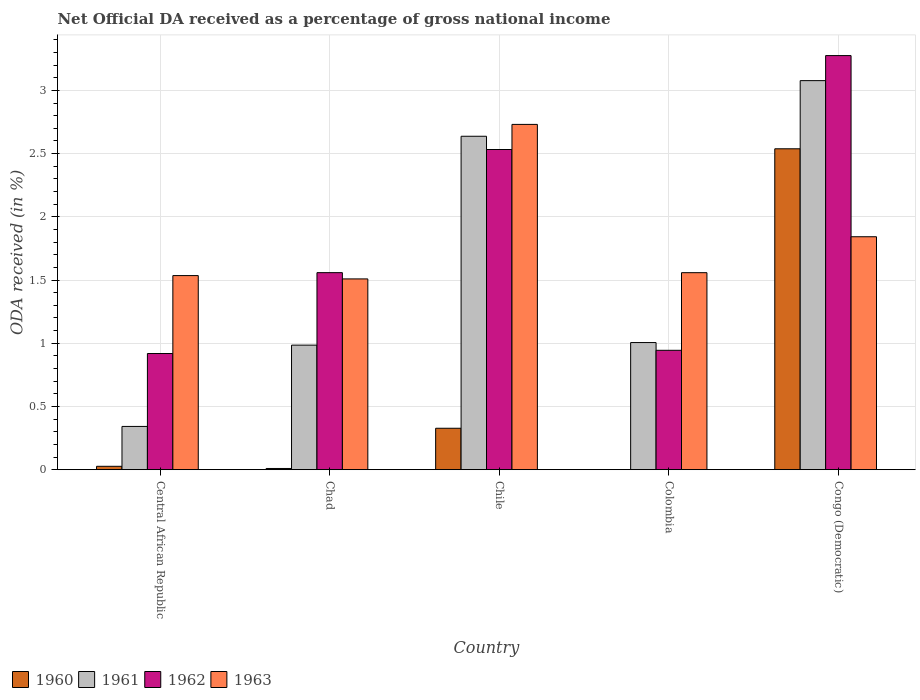How many different coloured bars are there?
Make the answer very short. 4. How many groups of bars are there?
Your response must be concise. 5. Are the number of bars per tick equal to the number of legend labels?
Keep it short and to the point. No. Are the number of bars on each tick of the X-axis equal?
Your answer should be very brief. No. How many bars are there on the 3rd tick from the right?
Provide a succinct answer. 4. What is the label of the 4th group of bars from the left?
Give a very brief answer. Colombia. In how many cases, is the number of bars for a given country not equal to the number of legend labels?
Offer a very short reply. 1. What is the net official DA received in 1963 in Colombia?
Give a very brief answer. 1.56. Across all countries, what is the maximum net official DA received in 1962?
Offer a terse response. 3.28. Across all countries, what is the minimum net official DA received in 1963?
Keep it short and to the point. 1.51. In which country was the net official DA received in 1961 maximum?
Your response must be concise. Congo (Democratic). What is the total net official DA received in 1963 in the graph?
Your answer should be very brief. 9.18. What is the difference between the net official DA received in 1960 in Chad and that in Chile?
Ensure brevity in your answer.  -0.32. What is the difference between the net official DA received in 1960 in Chad and the net official DA received in 1961 in Colombia?
Your answer should be very brief. -1. What is the average net official DA received in 1961 per country?
Your response must be concise. 1.61. What is the difference between the net official DA received of/in 1963 and net official DA received of/in 1960 in Congo (Democratic)?
Offer a very short reply. -0.7. What is the ratio of the net official DA received in 1960 in Chad to that in Chile?
Offer a terse response. 0.03. Is the difference between the net official DA received in 1963 in Chile and Congo (Democratic) greater than the difference between the net official DA received in 1960 in Chile and Congo (Democratic)?
Keep it short and to the point. Yes. What is the difference between the highest and the second highest net official DA received in 1962?
Offer a terse response. -0.97. What is the difference between the highest and the lowest net official DA received in 1961?
Your answer should be very brief. 2.73. Is the sum of the net official DA received in 1962 in Chile and Congo (Democratic) greater than the maximum net official DA received in 1960 across all countries?
Give a very brief answer. Yes. Where does the legend appear in the graph?
Keep it short and to the point. Bottom left. What is the title of the graph?
Offer a very short reply. Net Official DA received as a percentage of gross national income. Does "1973" appear as one of the legend labels in the graph?
Your answer should be compact. No. What is the label or title of the Y-axis?
Give a very brief answer. ODA received (in %). What is the ODA received (in %) in 1960 in Central African Republic?
Ensure brevity in your answer.  0.03. What is the ODA received (in %) of 1961 in Central African Republic?
Provide a succinct answer. 0.34. What is the ODA received (in %) of 1962 in Central African Republic?
Make the answer very short. 0.92. What is the ODA received (in %) of 1963 in Central African Republic?
Your answer should be very brief. 1.54. What is the ODA received (in %) in 1960 in Chad?
Give a very brief answer. 0.01. What is the ODA received (in %) of 1961 in Chad?
Give a very brief answer. 0.99. What is the ODA received (in %) in 1962 in Chad?
Your response must be concise. 1.56. What is the ODA received (in %) in 1963 in Chad?
Keep it short and to the point. 1.51. What is the ODA received (in %) of 1960 in Chile?
Ensure brevity in your answer.  0.33. What is the ODA received (in %) of 1961 in Chile?
Provide a short and direct response. 2.64. What is the ODA received (in %) in 1962 in Chile?
Offer a terse response. 2.53. What is the ODA received (in %) of 1963 in Chile?
Make the answer very short. 2.73. What is the ODA received (in %) of 1961 in Colombia?
Make the answer very short. 1.01. What is the ODA received (in %) in 1962 in Colombia?
Provide a short and direct response. 0.94. What is the ODA received (in %) in 1963 in Colombia?
Provide a short and direct response. 1.56. What is the ODA received (in %) in 1960 in Congo (Democratic)?
Make the answer very short. 2.54. What is the ODA received (in %) in 1961 in Congo (Democratic)?
Your answer should be very brief. 3.08. What is the ODA received (in %) of 1962 in Congo (Democratic)?
Ensure brevity in your answer.  3.28. What is the ODA received (in %) in 1963 in Congo (Democratic)?
Provide a succinct answer. 1.84. Across all countries, what is the maximum ODA received (in %) of 1960?
Your answer should be compact. 2.54. Across all countries, what is the maximum ODA received (in %) of 1961?
Offer a terse response. 3.08. Across all countries, what is the maximum ODA received (in %) of 1962?
Make the answer very short. 3.28. Across all countries, what is the maximum ODA received (in %) in 1963?
Offer a very short reply. 2.73. Across all countries, what is the minimum ODA received (in %) in 1961?
Your response must be concise. 0.34. Across all countries, what is the minimum ODA received (in %) of 1962?
Your answer should be compact. 0.92. Across all countries, what is the minimum ODA received (in %) in 1963?
Keep it short and to the point. 1.51. What is the total ODA received (in %) of 1960 in the graph?
Provide a short and direct response. 2.9. What is the total ODA received (in %) in 1961 in the graph?
Provide a short and direct response. 8.05. What is the total ODA received (in %) in 1962 in the graph?
Offer a very short reply. 9.23. What is the total ODA received (in %) in 1963 in the graph?
Give a very brief answer. 9.18. What is the difference between the ODA received (in %) in 1960 in Central African Republic and that in Chad?
Your answer should be very brief. 0.02. What is the difference between the ODA received (in %) in 1961 in Central African Republic and that in Chad?
Ensure brevity in your answer.  -0.64. What is the difference between the ODA received (in %) in 1962 in Central African Republic and that in Chad?
Make the answer very short. -0.64. What is the difference between the ODA received (in %) of 1963 in Central African Republic and that in Chad?
Your response must be concise. 0.03. What is the difference between the ODA received (in %) of 1960 in Central African Republic and that in Chile?
Provide a short and direct response. -0.3. What is the difference between the ODA received (in %) in 1961 in Central African Republic and that in Chile?
Keep it short and to the point. -2.29. What is the difference between the ODA received (in %) in 1962 in Central African Republic and that in Chile?
Make the answer very short. -1.61. What is the difference between the ODA received (in %) in 1963 in Central African Republic and that in Chile?
Your answer should be compact. -1.2. What is the difference between the ODA received (in %) of 1961 in Central African Republic and that in Colombia?
Provide a succinct answer. -0.66. What is the difference between the ODA received (in %) of 1962 in Central African Republic and that in Colombia?
Your response must be concise. -0.03. What is the difference between the ODA received (in %) in 1963 in Central African Republic and that in Colombia?
Your answer should be very brief. -0.02. What is the difference between the ODA received (in %) in 1960 in Central African Republic and that in Congo (Democratic)?
Keep it short and to the point. -2.51. What is the difference between the ODA received (in %) in 1961 in Central African Republic and that in Congo (Democratic)?
Ensure brevity in your answer.  -2.73. What is the difference between the ODA received (in %) of 1962 in Central African Republic and that in Congo (Democratic)?
Give a very brief answer. -2.36. What is the difference between the ODA received (in %) of 1963 in Central African Republic and that in Congo (Democratic)?
Offer a very short reply. -0.31. What is the difference between the ODA received (in %) in 1960 in Chad and that in Chile?
Make the answer very short. -0.32. What is the difference between the ODA received (in %) of 1961 in Chad and that in Chile?
Your answer should be compact. -1.65. What is the difference between the ODA received (in %) in 1962 in Chad and that in Chile?
Make the answer very short. -0.97. What is the difference between the ODA received (in %) in 1963 in Chad and that in Chile?
Your answer should be compact. -1.22. What is the difference between the ODA received (in %) in 1961 in Chad and that in Colombia?
Give a very brief answer. -0.02. What is the difference between the ODA received (in %) in 1962 in Chad and that in Colombia?
Your answer should be compact. 0.61. What is the difference between the ODA received (in %) of 1963 in Chad and that in Colombia?
Make the answer very short. -0.05. What is the difference between the ODA received (in %) in 1960 in Chad and that in Congo (Democratic)?
Make the answer very short. -2.53. What is the difference between the ODA received (in %) of 1961 in Chad and that in Congo (Democratic)?
Your response must be concise. -2.09. What is the difference between the ODA received (in %) of 1962 in Chad and that in Congo (Democratic)?
Give a very brief answer. -1.72. What is the difference between the ODA received (in %) in 1963 in Chad and that in Congo (Democratic)?
Give a very brief answer. -0.33. What is the difference between the ODA received (in %) of 1961 in Chile and that in Colombia?
Offer a terse response. 1.63. What is the difference between the ODA received (in %) in 1962 in Chile and that in Colombia?
Offer a very short reply. 1.59. What is the difference between the ODA received (in %) in 1963 in Chile and that in Colombia?
Provide a short and direct response. 1.17. What is the difference between the ODA received (in %) in 1960 in Chile and that in Congo (Democratic)?
Give a very brief answer. -2.21. What is the difference between the ODA received (in %) of 1961 in Chile and that in Congo (Democratic)?
Ensure brevity in your answer.  -0.44. What is the difference between the ODA received (in %) in 1962 in Chile and that in Congo (Democratic)?
Keep it short and to the point. -0.74. What is the difference between the ODA received (in %) of 1963 in Chile and that in Congo (Democratic)?
Make the answer very short. 0.89. What is the difference between the ODA received (in %) in 1961 in Colombia and that in Congo (Democratic)?
Offer a very short reply. -2.07. What is the difference between the ODA received (in %) of 1962 in Colombia and that in Congo (Democratic)?
Ensure brevity in your answer.  -2.33. What is the difference between the ODA received (in %) of 1963 in Colombia and that in Congo (Democratic)?
Your response must be concise. -0.28. What is the difference between the ODA received (in %) in 1960 in Central African Republic and the ODA received (in %) in 1961 in Chad?
Keep it short and to the point. -0.96. What is the difference between the ODA received (in %) of 1960 in Central African Republic and the ODA received (in %) of 1962 in Chad?
Offer a terse response. -1.53. What is the difference between the ODA received (in %) in 1960 in Central African Republic and the ODA received (in %) in 1963 in Chad?
Provide a short and direct response. -1.48. What is the difference between the ODA received (in %) of 1961 in Central African Republic and the ODA received (in %) of 1962 in Chad?
Ensure brevity in your answer.  -1.22. What is the difference between the ODA received (in %) of 1961 in Central African Republic and the ODA received (in %) of 1963 in Chad?
Offer a terse response. -1.17. What is the difference between the ODA received (in %) of 1962 in Central African Republic and the ODA received (in %) of 1963 in Chad?
Make the answer very short. -0.59. What is the difference between the ODA received (in %) of 1960 in Central African Republic and the ODA received (in %) of 1961 in Chile?
Give a very brief answer. -2.61. What is the difference between the ODA received (in %) of 1960 in Central African Republic and the ODA received (in %) of 1962 in Chile?
Provide a succinct answer. -2.51. What is the difference between the ODA received (in %) of 1960 in Central African Republic and the ODA received (in %) of 1963 in Chile?
Your answer should be compact. -2.7. What is the difference between the ODA received (in %) in 1961 in Central African Republic and the ODA received (in %) in 1962 in Chile?
Your answer should be very brief. -2.19. What is the difference between the ODA received (in %) of 1961 in Central African Republic and the ODA received (in %) of 1963 in Chile?
Your answer should be very brief. -2.39. What is the difference between the ODA received (in %) of 1962 in Central African Republic and the ODA received (in %) of 1963 in Chile?
Provide a short and direct response. -1.81. What is the difference between the ODA received (in %) in 1960 in Central African Republic and the ODA received (in %) in 1961 in Colombia?
Provide a short and direct response. -0.98. What is the difference between the ODA received (in %) of 1960 in Central African Republic and the ODA received (in %) of 1962 in Colombia?
Your answer should be very brief. -0.92. What is the difference between the ODA received (in %) of 1960 in Central African Republic and the ODA received (in %) of 1963 in Colombia?
Your answer should be very brief. -1.53. What is the difference between the ODA received (in %) of 1961 in Central African Republic and the ODA received (in %) of 1962 in Colombia?
Ensure brevity in your answer.  -0.6. What is the difference between the ODA received (in %) of 1961 in Central African Republic and the ODA received (in %) of 1963 in Colombia?
Your response must be concise. -1.22. What is the difference between the ODA received (in %) in 1962 in Central African Republic and the ODA received (in %) in 1963 in Colombia?
Provide a short and direct response. -0.64. What is the difference between the ODA received (in %) of 1960 in Central African Republic and the ODA received (in %) of 1961 in Congo (Democratic)?
Provide a succinct answer. -3.05. What is the difference between the ODA received (in %) of 1960 in Central African Republic and the ODA received (in %) of 1962 in Congo (Democratic)?
Your answer should be very brief. -3.25. What is the difference between the ODA received (in %) of 1960 in Central African Republic and the ODA received (in %) of 1963 in Congo (Democratic)?
Give a very brief answer. -1.82. What is the difference between the ODA received (in %) of 1961 in Central African Republic and the ODA received (in %) of 1962 in Congo (Democratic)?
Ensure brevity in your answer.  -2.93. What is the difference between the ODA received (in %) of 1961 in Central African Republic and the ODA received (in %) of 1963 in Congo (Democratic)?
Your response must be concise. -1.5. What is the difference between the ODA received (in %) of 1962 in Central African Republic and the ODA received (in %) of 1963 in Congo (Democratic)?
Make the answer very short. -0.92. What is the difference between the ODA received (in %) in 1960 in Chad and the ODA received (in %) in 1961 in Chile?
Keep it short and to the point. -2.63. What is the difference between the ODA received (in %) in 1960 in Chad and the ODA received (in %) in 1962 in Chile?
Keep it short and to the point. -2.52. What is the difference between the ODA received (in %) of 1960 in Chad and the ODA received (in %) of 1963 in Chile?
Provide a succinct answer. -2.72. What is the difference between the ODA received (in %) in 1961 in Chad and the ODA received (in %) in 1962 in Chile?
Your answer should be very brief. -1.55. What is the difference between the ODA received (in %) of 1961 in Chad and the ODA received (in %) of 1963 in Chile?
Provide a succinct answer. -1.75. What is the difference between the ODA received (in %) in 1962 in Chad and the ODA received (in %) in 1963 in Chile?
Your response must be concise. -1.17. What is the difference between the ODA received (in %) in 1960 in Chad and the ODA received (in %) in 1961 in Colombia?
Your answer should be very brief. -1. What is the difference between the ODA received (in %) in 1960 in Chad and the ODA received (in %) in 1962 in Colombia?
Offer a terse response. -0.93. What is the difference between the ODA received (in %) in 1960 in Chad and the ODA received (in %) in 1963 in Colombia?
Make the answer very short. -1.55. What is the difference between the ODA received (in %) of 1961 in Chad and the ODA received (in %) of 1962 in Colombia?
Your answer should be very brief. 0.04. What is the difference between the ODA received (in %) of 1961 in Chad and the ODA received (in %) of 1963 in Colombia?
Your answer should be very brief. -0.57. What is the difference between the ODA received (in %) of 1962 in Chad and the ODA received (in %) of 1963 in Colombia?
Keep it short and to the point. 0. What is the difference between the ODA received (in %) of 1960 in Chad and the ODA received (in %) of 1961 in Congo (Democratic)?
Your response must be concise. -3.07. What is the difference between the ODA received (in %) in 1960 in Chad and the ODA received (in %) in 1962 in Congo (Democratic)?
Offer a terse response. -3.27. What is the difference between the ODA received (in %) in 1960 in Chad and the ODA received (in %) in 1963 in Congo (Democratic)?
Your response must be concise. -1.83. What is the difference between the ODA received (in %) in 1961 in Chad and the ODA received (in %) in 1962 in Congo (Democratic)?
Your answer should be compact. -2.29. What is the difference between the ODA received (in %) in 1961 in Chad and the ODA received (in %) in 1963 in Congo (Democratic)?
Give a very brief answer. -0.86. What is the difference between the ODA received (in %) in 1962 in Chad and the ODA received (in %) in 1963 in Congo (Democratic)?
Offer a very short reply. -0.28. What is the difference between the ODA received (in %) in 1960 in Chile and the ODA received (in %) in 1961 in Colombia?
Keep it short and to the point. -0.68. What is the difference between the ODA received (in %) in 1960 in Chile and the ODA received (in %) in 1962 in Colombia?
Provide a short and direct response. -0.62. What is the difference between the ODA received (in %) in 1960 in Chile and the ODA received (in %) in 1963 in Colombia?
Ensure brevity in your answer.  -1.23. What is the difference between the ODA received (in %) of 1961 in Chile and the ODA received (in %) of 1962 in Colombia?
Your answer should be compact. 1.69. What is the difference between the ODA received (in %) in 1961 in Chile and the ODA received (in %) in 1963 in Colombia?
Provide a short and direct response. 1.08. What is the difference between the ODA received (in %) of 1962 in Chile and the ODA received (in %) of 1963 in Colombia?
Keep it short and to the point. 0.97. What is the difference between the ODA received (in %) in 1960 in Chile and the ODA received (in %) in 1961 in Congo (Democratic)?
Make the answer very short. -2.75. What is the difference between the ODA received (in %) of 1960 in Chile and the ODA received (in %) of 1962 in Congo (Democratic)?
Offer a terse response. -2.95. What is the difference between the ODA received (in %) of 1960 in Chile and the ODA received (in %) of 1963 in Congo (Democratic)?
Provide a short and direct response. -1.51. What is the difference between the ODA received (in %) in 1961 in Chile and the ODA received (in %) in 1962 in Congo (Democratic)?
Offer a terse response. -0.64. What is the difference between the ODA received (in %) in 1961 in Chile and the ODA received (in %) in 1963 in Congo (Democratic)?
Ensure brevity in your answer.  0.79. What is the difference between the ODA received (in %) of 1962 in Chile and the ODA received (in %) of 1963 in Congo (Democratic)?
Make the answer very short. 0.69. What is the difference between the ODA received (in %) of 1961 in Colombia and the ODA received (in %) of 1962 in Congo (Democratic)?
Make the answer very short. -2.27. What is the difference between the ODA received (in %) of 1961 in Colombia and the ODA received (in %) of 1963 in Congo (Democratic)?
Provide a succinct answer. -0.84. What is the difference between the ODA received (in %) in 1962 in Colombia and the ODA received (in %) in 1963 in Congo (Democratic)?
Ensure brevity in your answer.  -0.9. What is the average ODA received (in %) in 1960 per country?
Provide a short and direct response. 0.58. What is the average ODA received (in %) in 1961 per country?
Keep it short and to the point. 1.61. What is the average ODA received (in %) in 1962 per country?
Your answer should be very brief. 1.85. What is the average ODA received (in %) in 1963 per country?
Offer a very short reply. 1.84. What is the difference between the ODA received (in %) of 1960 and ODA received (in %) of 1961 in Central African Republic?
Make the answer very short. -0.32. What is the difference between the ODA received (in %) of 1960 and ODA received (in %) of 1962 in Central African Republic?
Ensure brevity in your answer.  -0.89. What is the difference between the ODA received (in %) of 1960 and ODA received (in %) of 1963 in Central African Republic?
Your answer should be compact. -1.51. What is the difference between the ODA received (in %) of 1961 and ODA received (in %) of 1962 in Central African Republic?
Your answer should be very brief. -0.58. What is the difference between the ODA received (in %) of 1961 and ODA received (in %) of 1963 in Central African Republic?
Provide a short and direct response. -1.19. What is the difference between the ODA received (in %) of 1962 and ODA received (in %) of 1963 in Central African Republic?
Make the answer very short. -0.62. What is the difference between the ODA received (in %) in 1960 and ODA received (in %) in 1961 in Chad?
Make the answer very short. -0.98. What is the difference between the ODA received (in %) of 1960 and ODA received (in %) of 1962 in Chad?
Keep it short and to the point. -1.55. What is the difference between the ODA received (in %) of 1960 and ODA received (in %) of 1963 in Chad?
Your answer should be compact. -1.5. What is the difference between the ODA received (in %) in 1961 and ODA received (in %) in 1962 in Chad?
Offer a very short reply. -0.57. What is the difference between the ODA received (in %) of 1961 and ODA received (in %) of 1963 in Chad?
Offer a terse response. -0.52. What is the difference between the ODA received (in %) in 1962 and ODA received (in %) in 1963 in Chad?
Keep it short and to the point. 0.05. What is the difference between the ODA received (in %) of 1960 and ODA received (in %) of 1961 in Chile?
Provide a short and direct response. -2.31. What is the difference between the ODA received (in %) in 1960 and ODA received (in %) in 1962 in Chile?
Keep it short and to the point. -2.2. What is the difference between the ODA received (in %) in 1960 and ODA received (in %) in 1963 in Chile?
Provide a short and direct response. -2.4. What is the difference between the ODA received (in %) in 1961 and ODA received (in %) in 1962 in Chile?
Offer a terse response. 0.1. What is the difference between the ODA received (in %) of 1961 and ODA received (in %) of 1963 in Chile?
Ensure brevity in your answer.  -0.09. What is the difference between the ODA received (in %) of 1962 and ODA received (in %) of 1963 in Chile?
Make the answer very short. -0.2. What is the difference between the ODA received (in %) of 1961 and ODA received (in %) of 1962 in Colombia?
Make the answer very short. 0.06. What is the difference between the ODA received (in %) of 1961 and ODA received (in %) of 1963 in Colombia?
Offer a terse response. -0.55. What is the difference between the ODA received (in %) of 1962 and ODA received (in %) of 1963 in Colombia?
Make the answer very short. -0.61. What is the difference between the ODA received (in %) of 1960 and ODA received (in %) of 1961 in Congo (Democratic)?
Your answer should be compact. -0.54. What is the difference between the ODA received (in %) of 1960 and ODA received (in %) of 1962 in Congo (Democratic)?
Offer a very short reply. -0.74. What is the difference between the ODA received (in %) in 1960 and ODA received (in %) in 1963 in Congo (Democratic)?
Your answer should be very brief. 0.7. What is the difference between the ODA received (in %) in 1961 and ODA received (in %) in 1962 in Congo (Democratic)?
Ensure brevity in your answer.  -0.2. What is the difference between the ODA received (in %) of 1961 and ODA received (in %) of 1963 in Congo (Democratic)?
Your answer should be very brief. 1.23. What is the difference between the ODA received (in %) of 1962 and ODA received (in %) of 1963 in Congo (Democratic)?
Make the answer very short. 1.43. What is the ratio of the ODA received (in %) of 1960 in Central African Republic to that in Chad?
Your response must be concise. 2.79. What is the ratio of the ODA received (in %) in 1961 in Central African Republic to that in Chad?
Offer a terse response. 0.35. What is the ratio of the ODA received (in %) of 1962 in Central African Republic to that in Chad?
Keep it short and to the point. 0.59. What is the ratio of the ODA received (in %) in 1963 in Central African Republic to that in Chad?
Give a very brief answer. 1.02. What is the ratio of the ODA received (in %) of 1960 in Central African Republic to that in Chile?
Keep it short and to the point. 0.08. What is the ratio of the ODA received (in %) in 1961 in Central African Republic to that in Chile?
Offer a terse response. 0.13. What is the ratio of the ODA received (in %) in 1962 in Central African Republic to that in Chile?
Provide a succinct answer. 0.36. What is the ratio of the ODA received (in %) in 1963 in Central African Republic to that in Chile?
Provide a short and direct response. 0.56. What is the ratio of the ODA received (in %) of 1961 in Central African Republic to that in Colombia?
Give a very brief answer. 0.34. What is the ratio of the ODA received (in %) in 1962 in Central African Republic to that in Colombia?
Ensure brevity in your answer.  0.97. What is the ratio of the ODA received (in %) in 1963 in Central African Republic to that in Colombia?
Give a very brief answer. 0.99. What is the ratio of the ODA received (in %) in 1960 in Central African Republic to that in Congo (Democratic)?
Ensure brevity in your answer.  0.01. What is the ratio of the ODA received (in %) of 1961 in Central African Republic to that in Congo (Democratic)?
Your answer should be very brief. 0.11. What is the ratio of the ODA received (in %) of 1962 in Central African Republic to that in Congo (Democratic)?
Ensure brevity in your answer.  0.28. What is the ratio of the ODA received (in %) in 1963 in Central African Republic to that in Congo (Democratic)?
Give a very brief answer. 0.83. What is the ratio of the ODA received (in %) of 1960 in Chad to that in Chile?
Your response must be concise. 0.03. What is the ratio of the ODA received (in %) in 1961 in Chad to that in Chile?
Provide a succinct answer. 0.37. What is the ratio of the ODA received (in %) in 1962 in Chad to that in Chile?
Your response must be concise. 0.62. What is the ratio of the ODA received (in %) in 1963 in Chad to that in Chile?
Your response must be concise. 0.55. What is the ratio of the ODA received (in %) of 1961 in Chad to that in Colombia?
Your response must be concise. 0.98. What is the ratio of the ODA received (in %) of 1962 in Chad to that in Colombia?
Provide a succinct answer. 1.65. What is the ratio of the ODA received (in %) in 1963 in Chad to that in Colombia?
Offer a terse response. 0.97. What is the ratio of the ODA received (in %) of 1960 in Chad to that in Congo (Democratic)?
Provide a short and direct response. 0. What is the ratio of the ODA received (in %) in 1961 in Chad to that in Congo (Democratic)?
Offer a very short reply. 0.32. What is the ratio of the ODA received (in %) in 1962 in Chad to that in Congo (Democratic)?
Offer a terse response. 0.48. What is the ratio of the ODA received (in %) of 1963 in Chad to that in Congo (Democratic)?
Provide a short and direct response. 0.82. What is the ratio of the ODA received (in %) of 1961 in Chile to that in Colombia?
Keep it short and to the point. 2.62. What is the ratio of the ODA received (in %) in 1962 in Chile to that in Colombia?
Keep it short and to the point. 2.68. What is the ratio of the ODA received (in %) in 1963 in Chile to that in Colombia?
Provide a succinct answer. 1.75. What is the ratio of the ODA received (in %) in 1960 in Chile to that in Congo (Democratic)?
Keep it short and to the point. 0.13. What is the ratio of the ODA received (in %) of 1961 in Chile to that in Congo (Democratic)?
Ensure brevity in your answer.  0.86. What is the ratio of the ODA received (in %) in 1962 in Chile to that in Congo (Democratic)?
Offer a very short reply. 0.77. What is the ratio of the ODA received (in %) of 1963 in Chile to that in Congo (Democratic)?
Your response must be concise. 1.48. What is the ratio of the ODA received (in %) in 1961 in Colombia to that in Congo (Democratic)?
Ensure brevity in your answer.  0.33. What is the ratio of the ODA received (in %) of 1962 in Colombia to that in Congo (Democratic)?
Offer a very short reply. 0.29. What is the ratio of the ODA received (in %) of 1963 in Colombia to that in Congo (Democratic)?
Make the answer very short. 0.85. What is the difference between the highest and the second highest ODA received (in %) in 1960?
Your answer should be compact. 2.21. What is the difference between the highest and the second highest ODA received (in %) of 1961?
Your answer should be very brief. 0.44. What is the difference between the highest and the second highest ODA received (in %) of 1962?
Give a very brief answer. 0.74. What is the difference between the highest and the second highest ODA received (in %) of 1963?
Make the answer very short. 0.89. What is the difference between the highest and the lowest ODA received (in %) of 1960?
Your response must be concise. 2.54. What is the difference between the highest and the lowest ODA received (in %) in 1961?
Your answer should be compact. 2.73. What is the difference between the highest and the lowest ODA received (in %) in 1962?
Make the answer very short. 2.36. What is the difference between the highest and the lowest ODA received (in %) in 1963?
Your response must be concise. 1.22. 